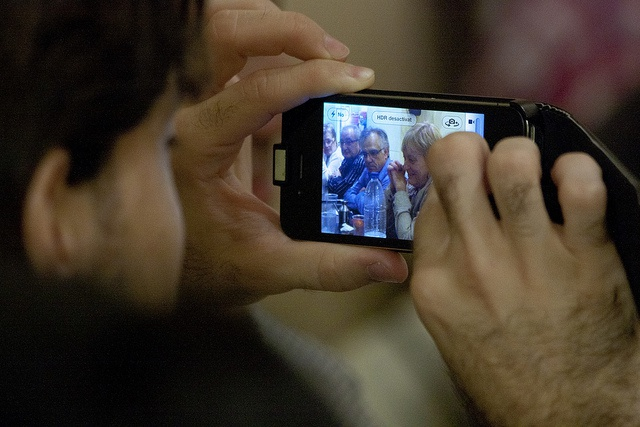Describe the objects in this image and their specific colors. I can see people in black, gray, and maroon tones, cell phone in black, lightblue, and gray tones, people in black, gray, and darkgray tones, people in black, blue, gray, darkblue, and purple tones, and people in black, navy, darkblue, and blue tones in this image. 